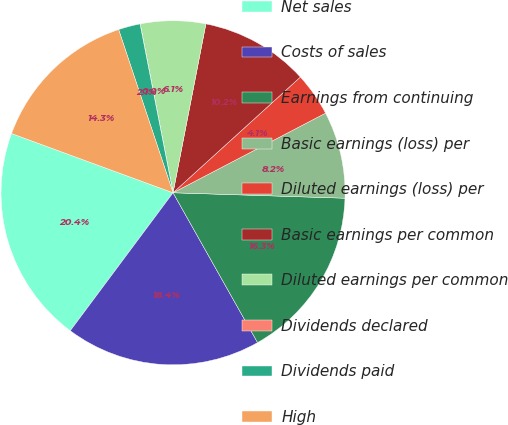Convert chart to OTSL. <chart><loc_0><loc_0><loc_500><loc_500><pie_chart><fcel>Net sales<fcel>Costs of sales<fcel>Earnings from continuing<fcel>Basic earnings (loss) per<fcel>Diluted earnings (loss) per<fcel>Basic earnings per common<fcel>Diluted earnings per common<fcel>Dividends declared<fcel>Dividends paid<fcel>High<nl><fcel>20.4%<fcel>18.36%<fcel>16.32%<fcel>8.16%<fcel>4.08%<fcel>10.2%<fcel>6.12%<fcel>0.01%<fcel>2.05%<fcel>14.28%<nl></chart> 